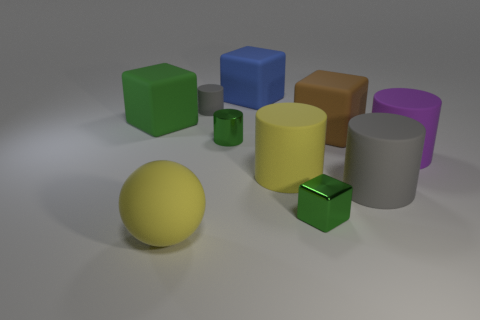Subtract all yellow cylinders. How many cylinders are left? 4 Subtract all purple blocks. How many gray cylinders are left? 2 Subtract 1 cylinders. How many cylinders are left? 4 Subtract all gray cylinders. How many cylinders are left? 3 Subtract all spheres. How many objects are left? 9 Subtract all cyan blocks. Subtract all brown balls. How many blocks are left? 4 Subtract all small matte cylinders. Subtract all yellow matte balls. How many objects are left? 8 Add 6 big purple rubber objects. How many big purple rubber objects are left? 7 Add 7 small metal cubes. How many small metal cubes exist? 8 Subtract 0 blue balls. How many objects are left? 10 